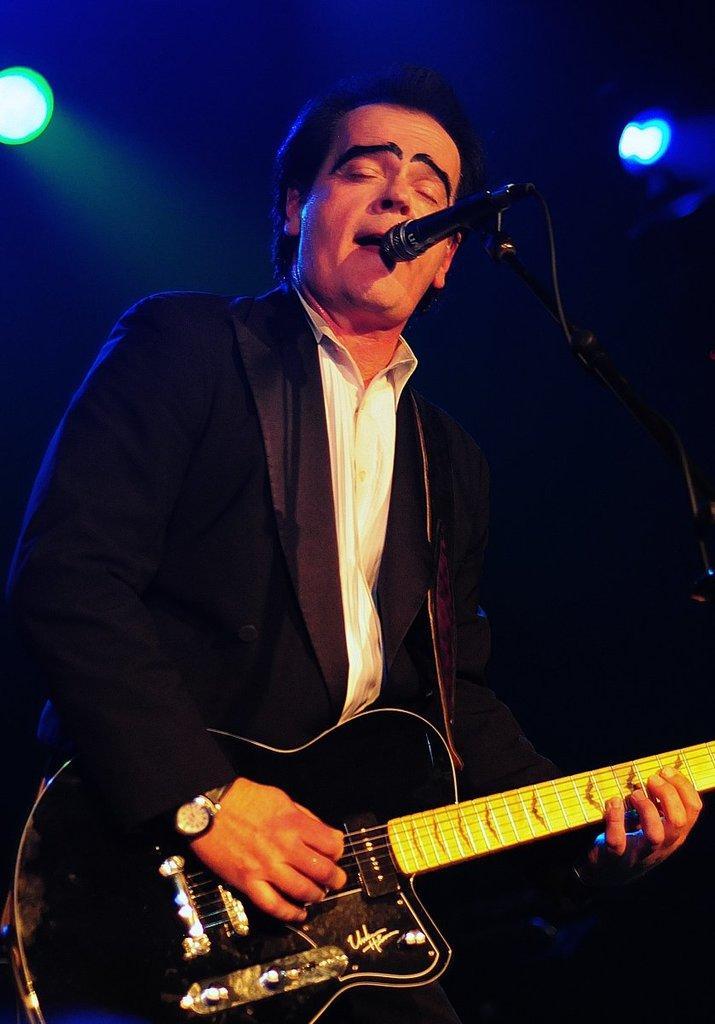Could you give a brief overview of what you see in this image? This picture is clicked inside. In the center there is a Man sitting, playing Guitar and singing. On the right there is a stand to which a microphone is attached. In the background there are some focusing lights. 